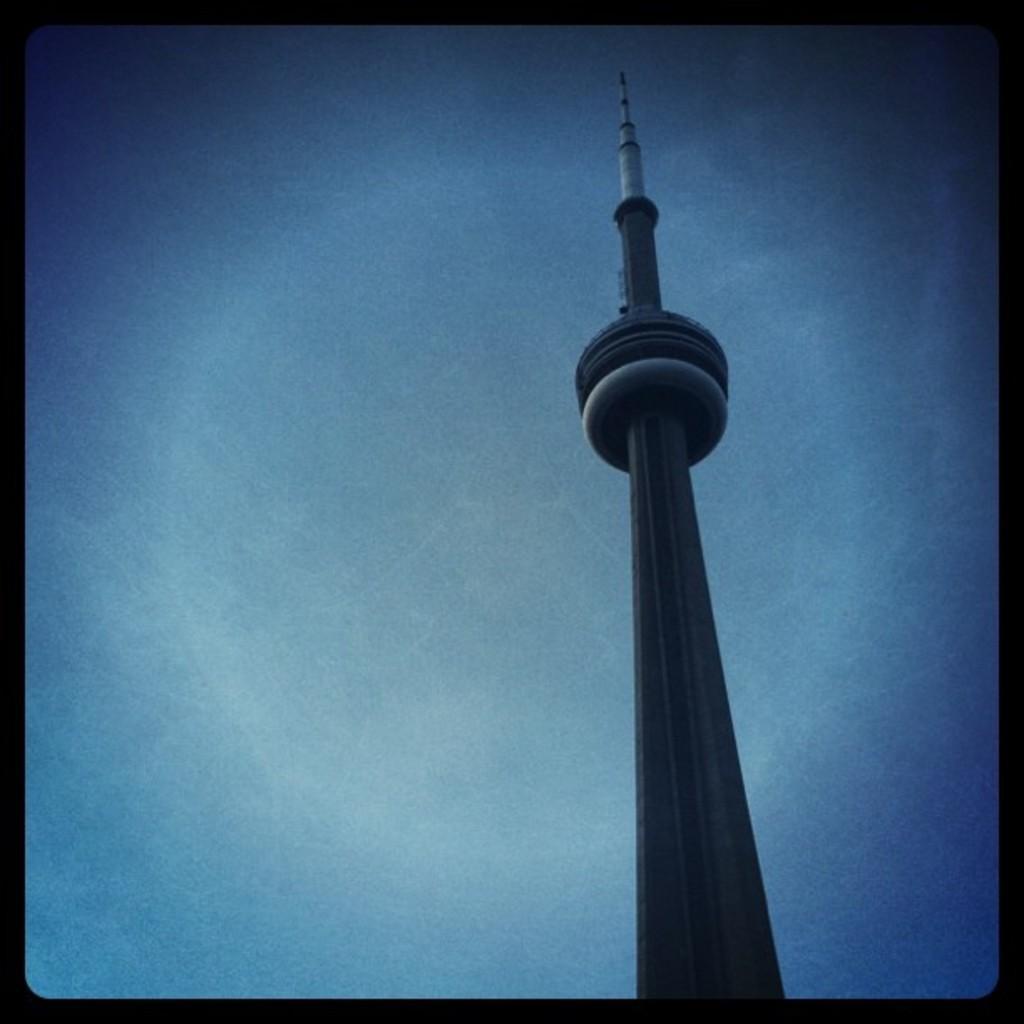Describe this image in one or two sentences. In this image we can see one big tower and the background there is the blue sky. 